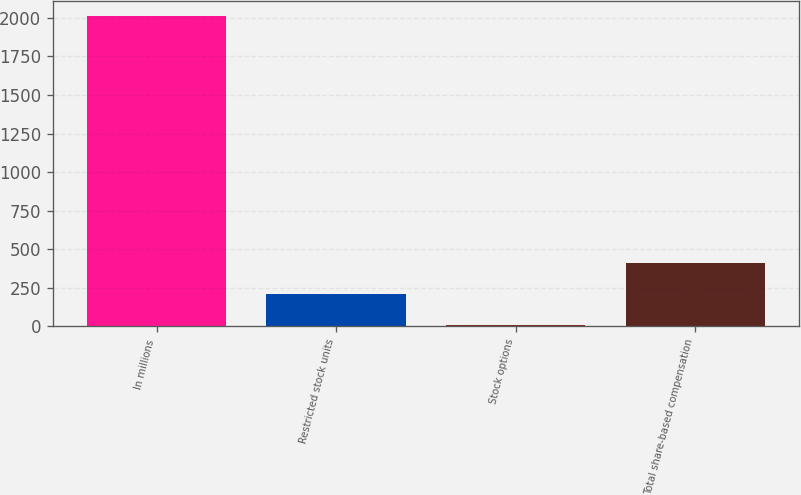<chart> <loc_0><loc_0><loc_500><loc_500><bar_chart><fcel>In millions<fcel>Restricted stock units<fcel>Stock options<fcel>Total share-based compensation<nl><fcel>2012<fcel>211.64<fcel>11.6<fcel>411.68<nl></chart> 